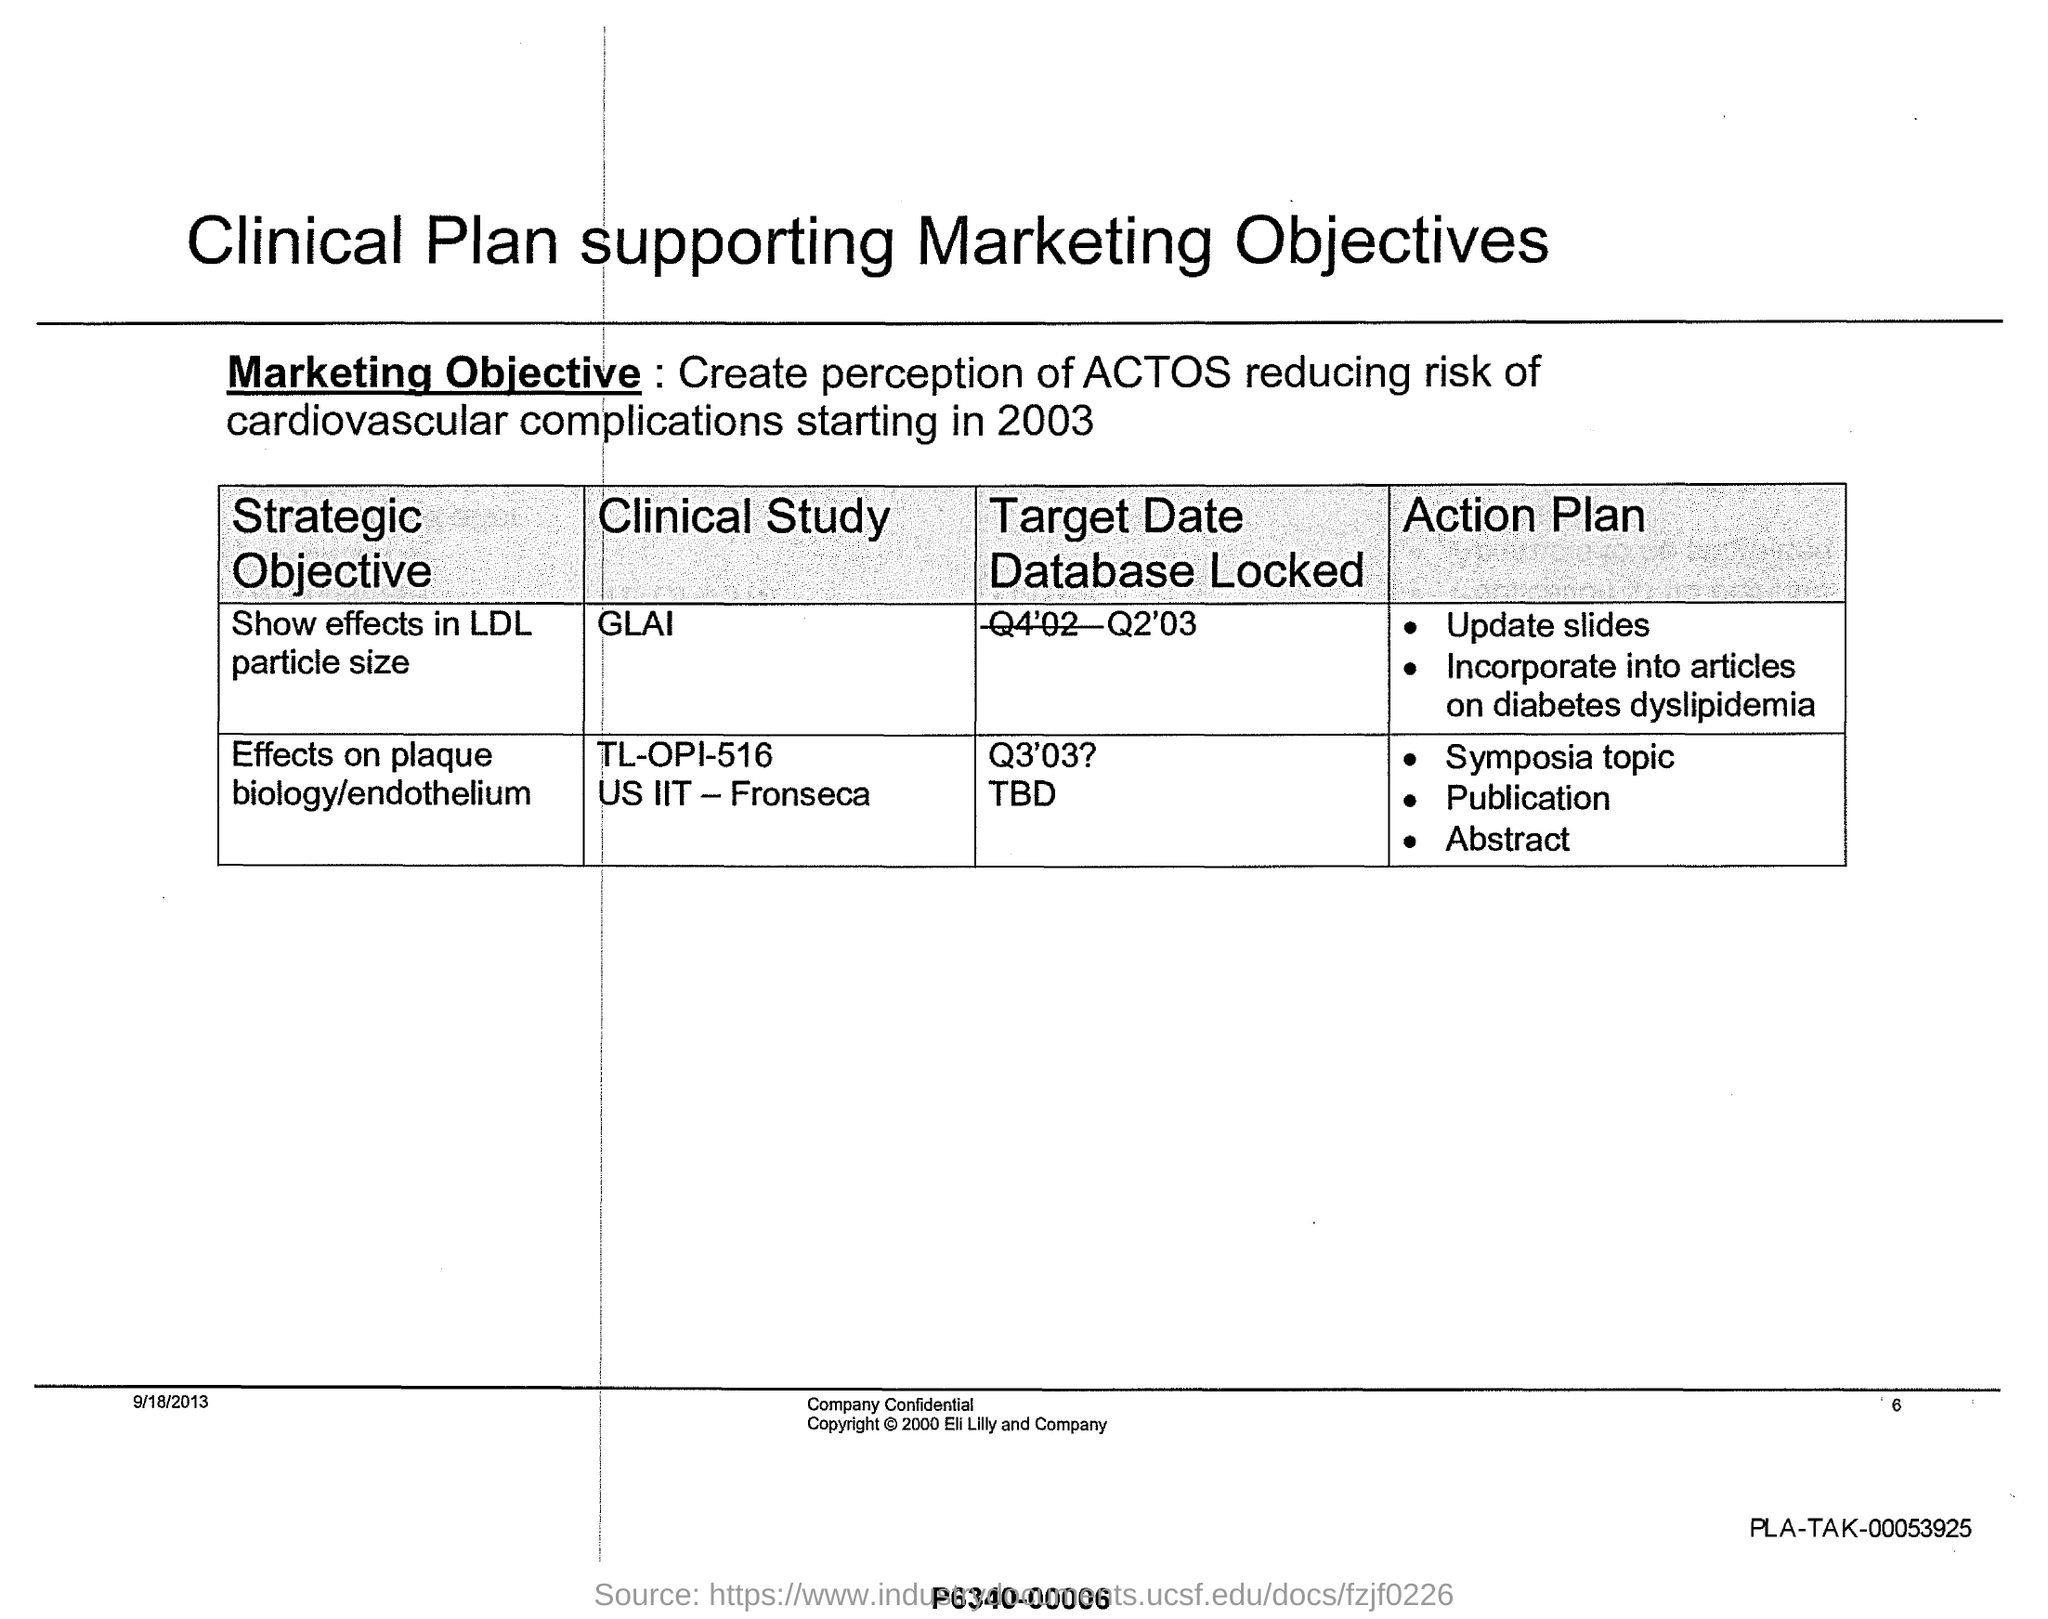What is the title of the document?
Ensure brevity in your answer.  Clinical Plan supporting Marketing Objectives. What is the first Strategic Objective?
Offer a very short reply. Show effects in LDL particle size. Who owns the Copyright?
Give a very brief answer. ELI LILLY AND COMPANY. What is the first 'Action Plan' for the objective "Effects on plaque biology/endothelium"?
Provide a short and direct response. Symposia topic. 